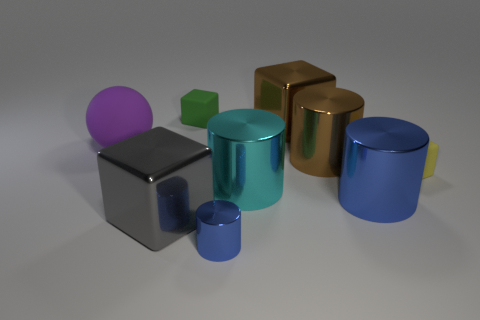Subtract all large brown shiny cylinders. How many cylinders are left? 3 Add 1 small yellow things. How many objects exist? 10 Subtract all green cubes. How many cubes are left? 3 Subtract all cubes. How many objects are left? 5 Subtract 3 blocks. How many blocks are left? 1 Add 3 brown metal objects. How many brown metal objects are left? 5 Add 7 brown cubes. How many brown cubes exist? 8 Subtract 0 yellow cylinders. How many objects are left? 9 Subtract all cyan cubes. Subtract all green cylinders. How many cubes are left? 4 Subtract all yellow cylinders. How many brown cubes are left? 1 